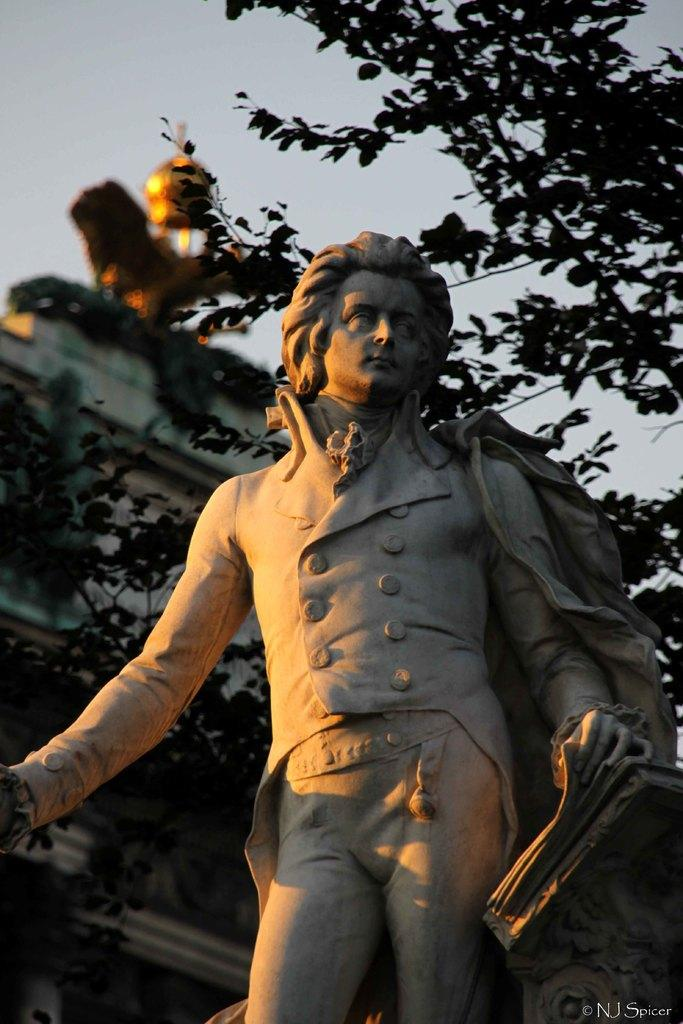What is the main subject in the center of the image? There is a statue in the center of the image. What can be seen in the background of the image? There is a building and branches of a tree visible in the background. What is visible above the statue and background? The sky is visible in the image. How would you describe the sky in the image? The sky appears to be cloudy. What is the name of the playground located near the statue in the image? There is no playground present in the image, so it is not possible to determine its name. 